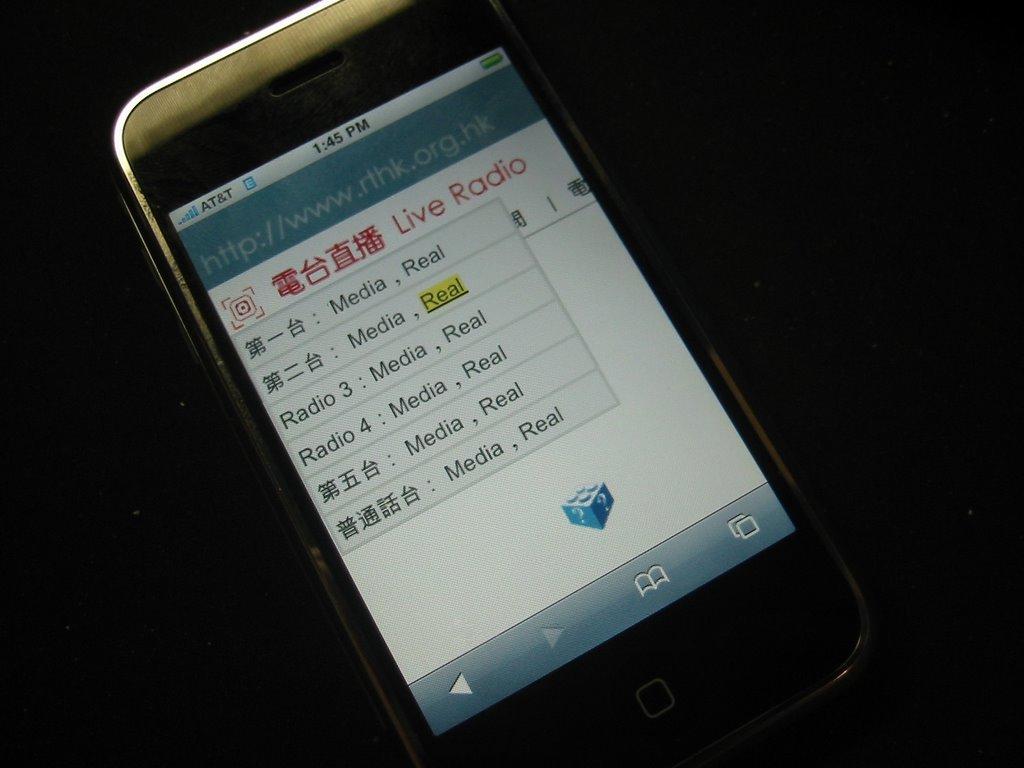What type of radio?
Give a very brief answer. Live. What time is at the top of the phone?
Offer a terse response. 1:45 pm. 